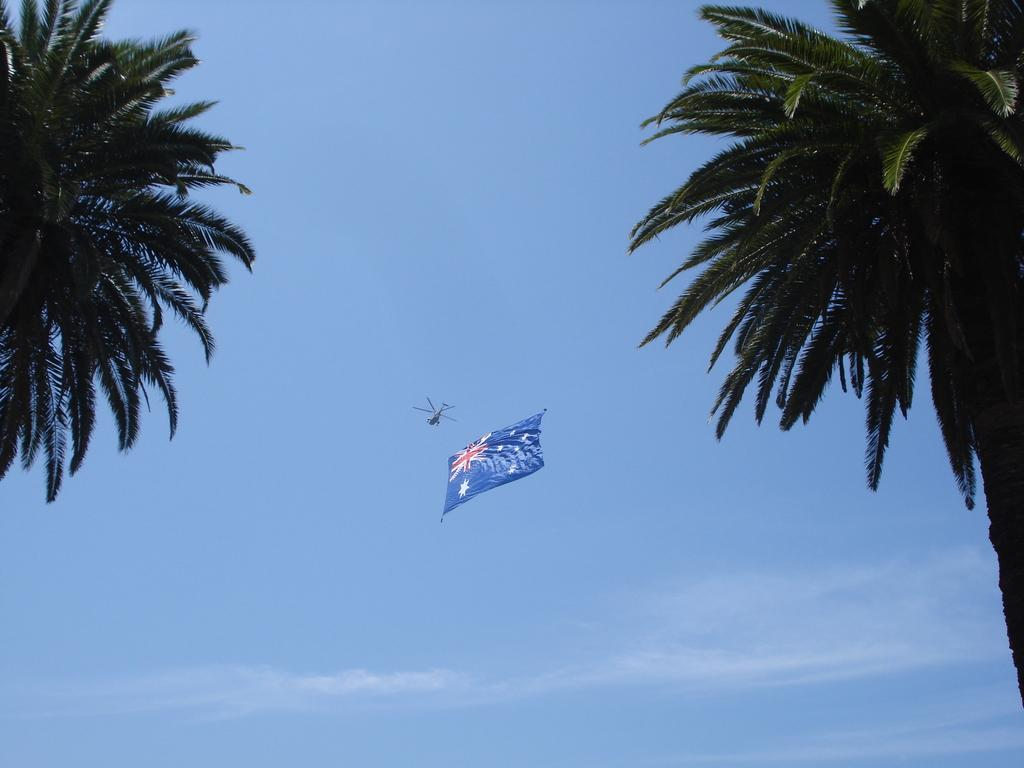What type of natural elements can be seen in the image? There are trees in the image. What man-made object is present in the image? There is an airplane in the image. What symbol can be seen in the image? There is a flag in the image. What part of the natural environment is visible in the image? The sky is visible in the image. What color is the sky in the image? The sky is blue in color. What type of current can be seen flowing through the trees in the image? There is no current visible in the image; it features trees, an airplane, a flag, and a blue sky. Is there a scarf tied around the flagpole in the image? There is no scarf present in the image; only the flag is visible. 